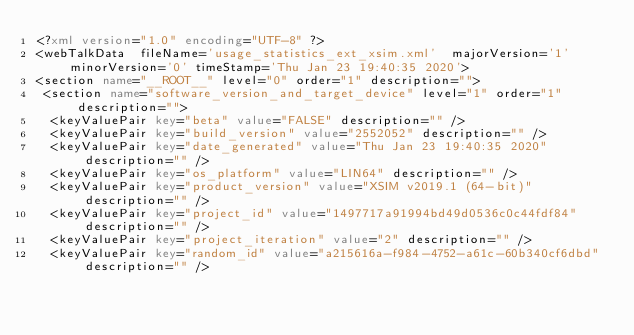Convert code to text. <code><loc_0><loc_0><loc_500><loc_500><_XML_><?xml version="1.0" encoding="UTF-8" ?>
<webTalkData  fileName='usage_statistics_ext_xsim.xml'  majorVersion='1' minorVersion='0' timeStamp='Thu Jan 23 19:40:35 2020'>
<section name="__ROOT__" level="0" order="1" description="">
 <section name="software_version_and_target_device" level="1" order="1" description="">
  <keyValuePair key="beta" value="FALSE" description="" />
  <keyValuePair key="build_version" value="2552052" description="" />
  <keyValuePair key="date_generated" value="Thu Jan 23 19:40:35 2020" description="" />
  <keyValuePair key="os_platform" value="LIN64" description="" />
  <keyValuePair key="product_version" value="XSIM v2019.1 (64-bit)" description="" />
  <keyValuePair key="project_id" value="1497717a91994bd49d0536c0c44fdf84" description="" />
  <keyValuePair key="project_iteration" value="2" description="" />
  <keyValuePair key="random_id" value="a215616a-f984-4752-a61c-60b340cf6dbd" description="" /></code> 